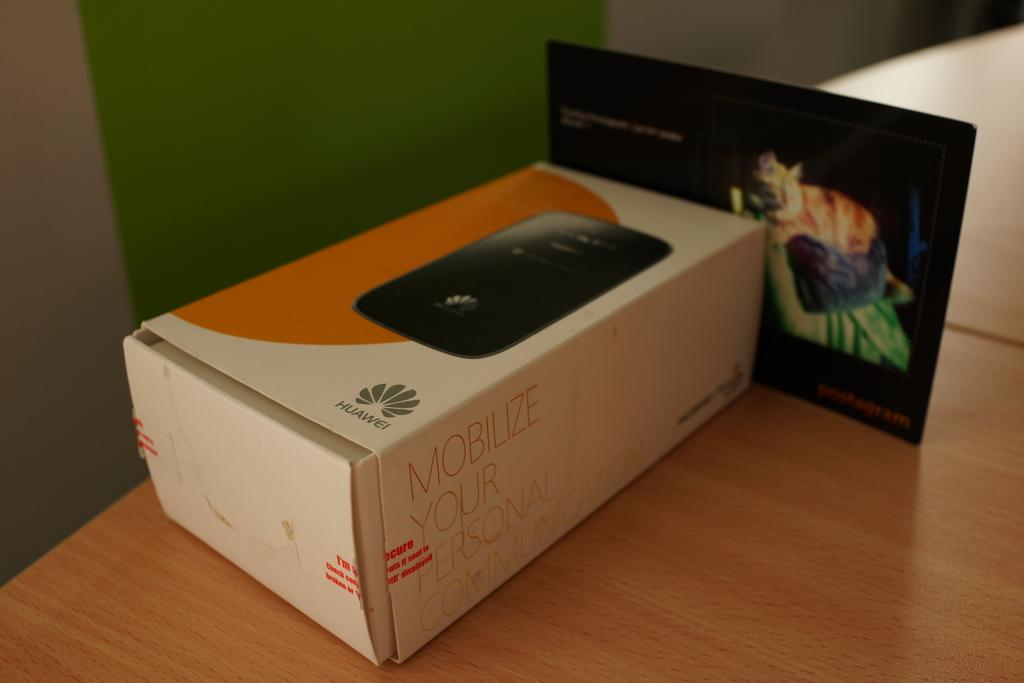<image>
Provide a brief description of the given image. A box for a phone which has the word Mobilize on it. 